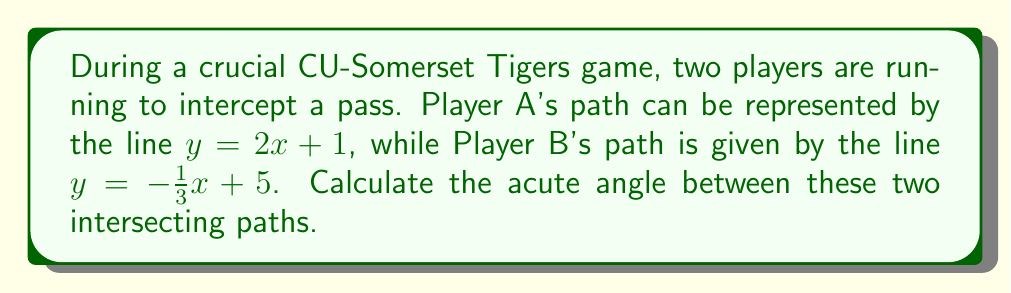Help me with this question. To solve this problem, we'll follow these steps:

1) The angle between two lines can be calculated using the formula:

   $$\tan \theta = \left|\frac{m_1 - m_2}{1 + m_1m_2}\right|$$

   where $m_1$ and $m_2$ are the slopes of the two lines.

2) From the given equations:
   Line A: $y = 2x + 1$, so $m_1 = 2$
   Line B: $y = -\frac{1}{3}x + 5$, so $m_2 = -\frac{1}{3}$

3) Substituting these values into the formula:

   $$\tan \theta = \left|\frac{2 - (-\frac{1}{3})}{1 + 2(-\frac{1}{3})}\right|$$

4) Simplify the numerator and denominator:

   $$\tan \theta = \left|\frac{2 + \frac{1}{3}}{1 - \frac{2}{3}}\right| = \left|\frac{\frac{7}{3}}{\frac{1}{3}}\right| = 7$$

5) To find $\theta$, we need to calculate the inverse tangent (arctangent):

   $$\theta = \arctan(7)$$

6) Using a calculator or trigonometric tables:

   $$\theta \approx 81.87^\circ$$

This is the acute angle between the two paths.
Answer: $81.87^\circ$ (rounded to two decimal places) 